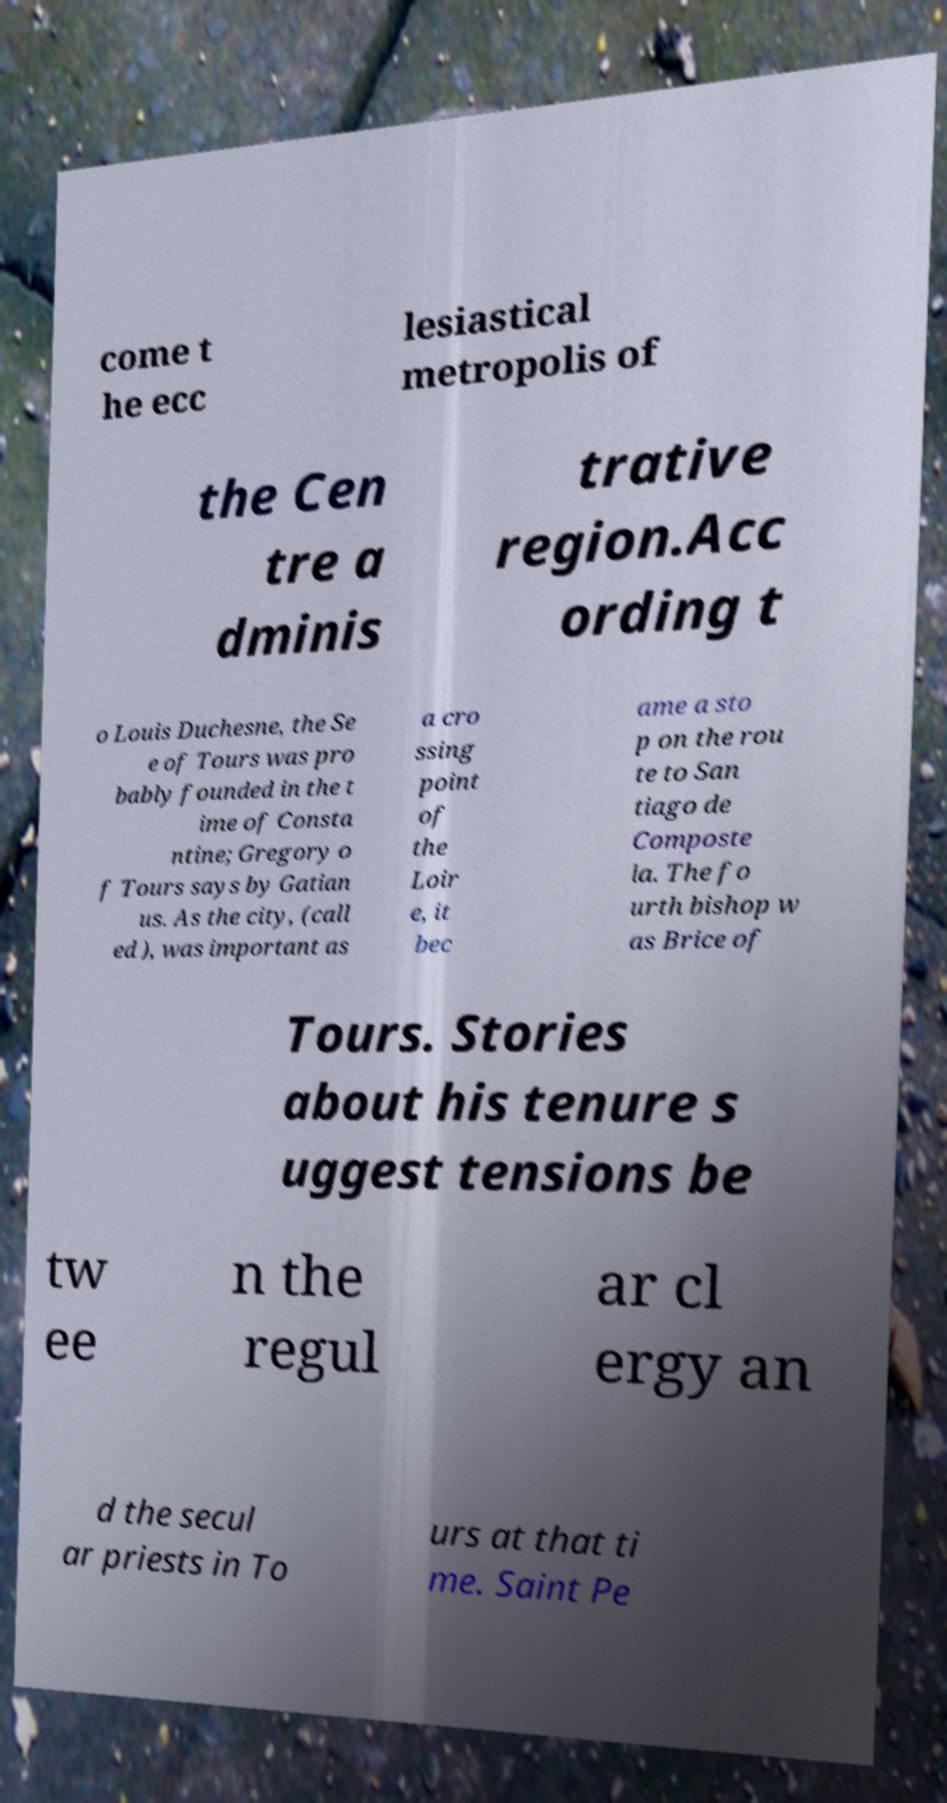Please identify and transcribe the text found in this image. come t he ecc lesiastical metropolis of the Cen tre a dminis trative region.Acc ording t o Louis Duchesne, the Se e of Tours was pro bably founded in the t ime of Consta ntine; Gregory o f Tours says by Gatian us. As the city, (call ed ), was important as a cro ssing point of the Loir e, it bec ame a sto p on the rou te to San tiago de Composte la. The fo urth bishop w as Brice of Tours. Stories about his tenure s uggest tensions be tw ee n the regul ar cl ergy an d the secul ar priests in To urs at that ti me. Saint Pe 